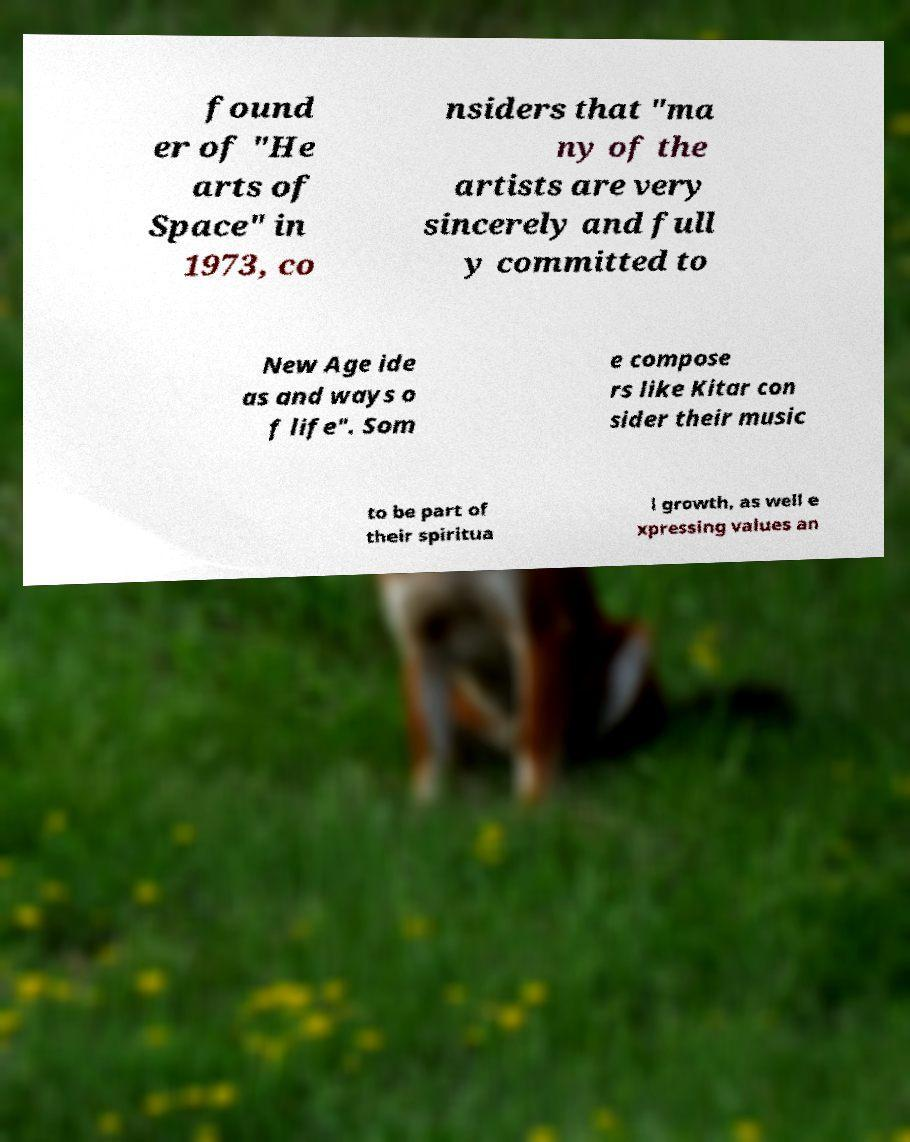What messages or text are displayed in this image? I need them in a readable, typed format. found er of "He arts of Space" in 1973, co nsiders that "ma ny of the artists are very sincerely and full y committed to New Age ide as and ways o f life". Som e compose rs like Kitar con sider their music to be part of their spiritua l growth, as well e xpressing values an 